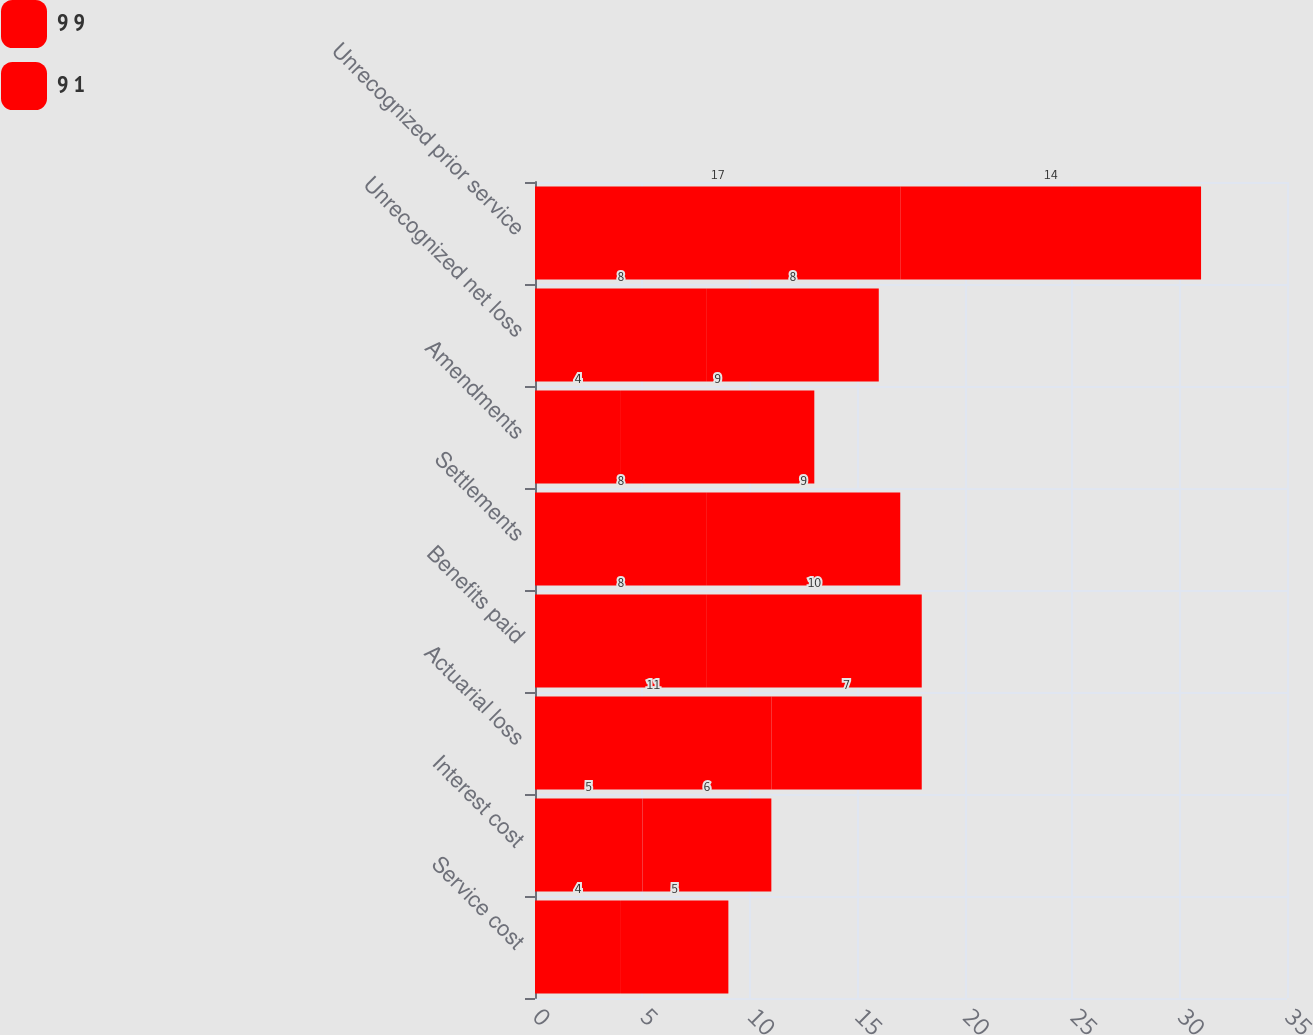Convert chart. <chart><loc_0><loc_0><loc_500><loc_500><stacked_bar_chart><ecel><fcel>Service cost<fcel>Interest cost<fcel>Actuarial loss<fcel>Benefits paid<fcel>Settlements<fcel>Amendments<fcel>Unrecognized net loss<fcel>Unrecognized prior service<nl><fcel>9 9<fcel>4<fcel>5<fcel>11<fcel>8<fcel>8<fcel>4<fcel>8<fcel>17<nl><fcel>9 1<fcel>5<fcel>6<fcel>7<fcel>10<fcel>9<fcel>9<fcel>8<fcel>14<nl></chart> 